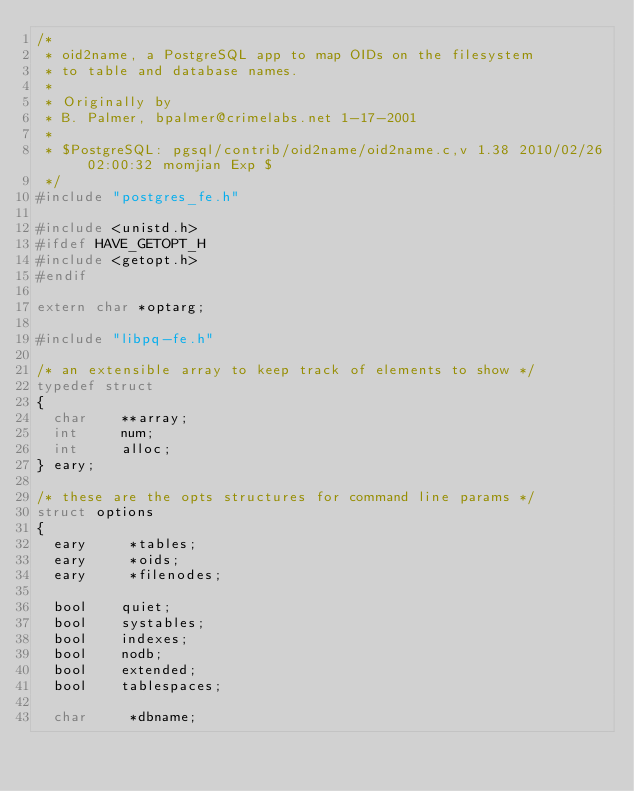Convert code to text. <code><loc_0><loc_0><loc_500><loc_500><_C_>/*
 * oid2name, a PostgreSQL app to map OIDs on the filesystem
 * to table and database names.
 *
 * Originally by
 * B. Palmer, bpalmer@crimelabs.net 1-17-2001
 *
 * $PostgreSQL: pgsql/contrib/oid2name/oid2name.c,v 1.38 2010/02/26 02:00:32 momjian Exp $
 */
#include "postgres_fe.h"

#include <unistd.h>
#ifdef HAVE_GETOPT_H
#include <getopt.h>
#endif

extern char *optarg;

#include "libpq-fe.h"

/* an extensible array to keep track of elements to show */
typedef struct
{
	char	  **array;
	int			num;
	int			alloc;
} eary;

/* these are the opts structures for command line params */
struct options
{
	eary	   *tables;
	eary	   *oids;
	eary	   *filenodes;

	bool		quiet;
	bool		systables;
	bool		indexes;
	bool		nodb;
	bool		extended;
	bool		tablespaces;

	char	   *dbname;</code> 